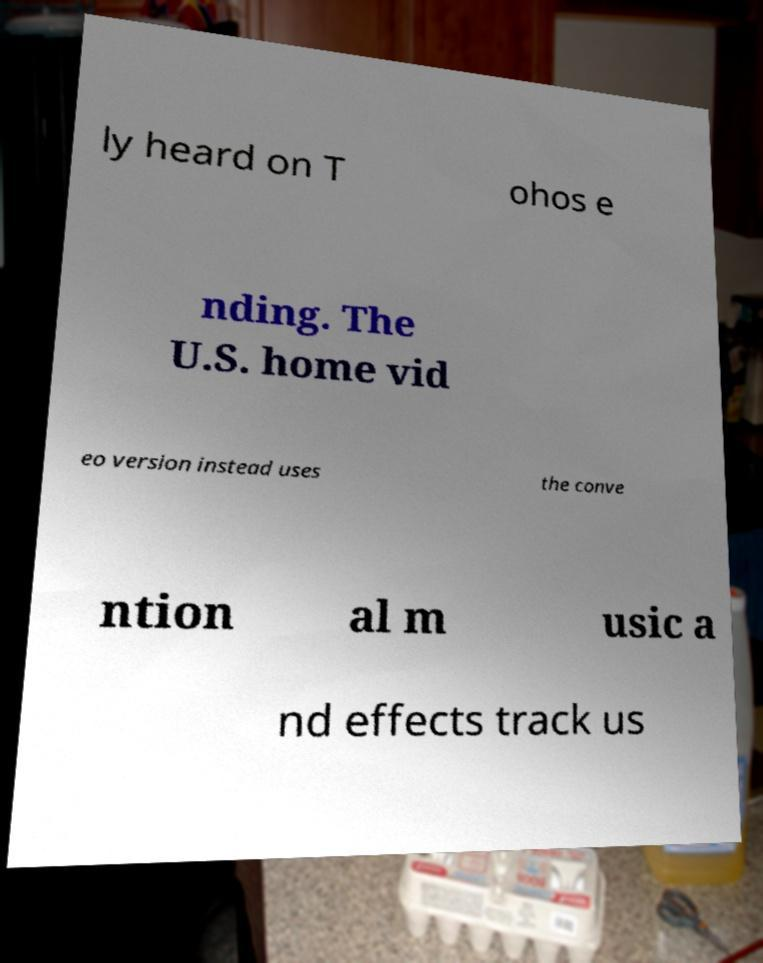Could you extract and type out the text from this image? ly heard on T ohos e nding. The U.S. home vid eo version instead uses the conve ntion al m usic a nd effects track us 